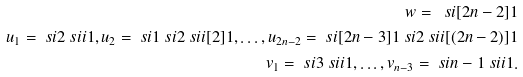<formula> <loc_0><loc_0><loc_500><loc_500>w = \ s i [ 2 n - 2 ] 1 \\ u _ { 1 } = \ s i { 2 } \ s i i { 1 } , u _ { 2 } = \ s i { 1 } \ s i { 2 } \ s i i [ 2 ] { 1 } , \dots , u _ { 2 n - 2 } = \ s i [ 2 n - 3 ] { 1 } \ s i { 2 } \ s i i [ ( 2 n - 2 ) ] { 1 } \\ v _ { 1 } = \ s i { 3 } \ s i i { 1 } , \dots , v _ { n - 3 } = \ s i { n - 1 } \ s i i { 1 } .</formula> 